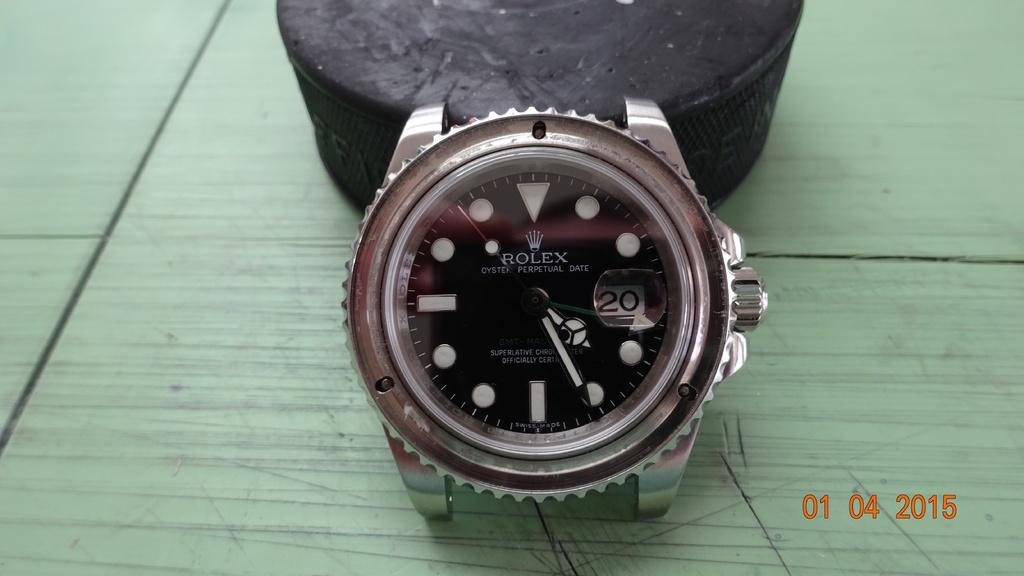<image>
Give a short and clear explanation of the subsequent image. A silver Rolex Oyster Perpetual Date wristwatch with the number 20. 